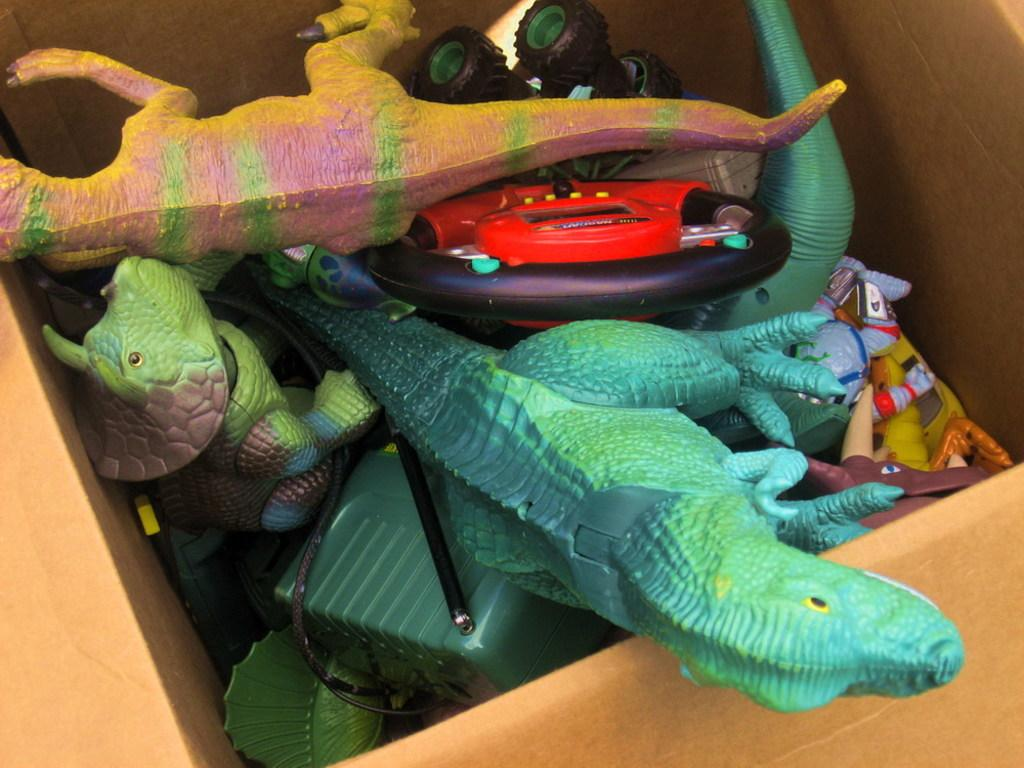What objects are in the cardboard box in the image? There are toys in a cardboard box in the image. How many feet can be seen in the image? There are no feet visible in the image; it features a cardboard box with toys inside. What type of metal is present in the image? There is no metal, including zinc, present in the image; it features a cardboard box with toys inside. 